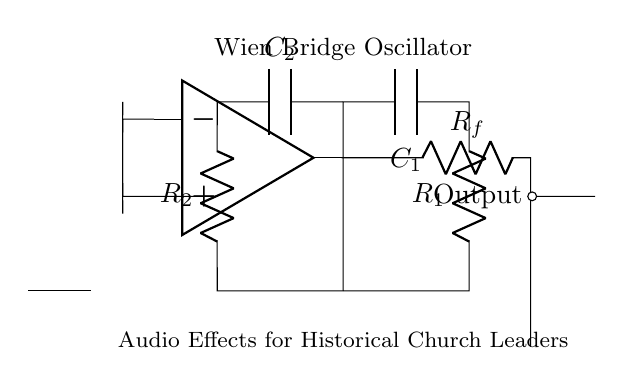What components are used in the Wien bridge oscillator? The circuit contains two resistors (R1, R2), two capacitors (C1, C2), and an operational amplifier (op amp).
Answer: resistors, capacitors, op amp What is the role of the op amp in this circuit? The op amp amplifies the voltage signal and is essential for sustaining oscillations in the Wien bridge oscillator.
Answer: amplifies voltage signal Which component connects the output to the rest of the circuit? The output is connected via a resistor labeled Rf, which links the op amp output back to the oscillator circuit.
Answer: Rf How many resistors are present in the circuit? The diagram shows a total of two resistors, R1 and R2, which are key components in determining the oscillation frequency.
Answer: 2 What does the output node indicate in the circuit? The output node shows where the generated oscillating signal is available for use, typically representing the audio output in this application.
Answer: generated oscillating signal Which capacitors are part of the feedback path? The capacitors C1 and C2 are involved in the feedback path, influencing the frequency response of the oscillator.
Answer: C1 and C2 What determines the frequency of oscillation in this circuit? The frequency of oscillation is determined by the values of resistors R1, R2, and capacitors C1, C2 in the oscillator circuit configuration.
Answer: R1, R2, C1, C2 